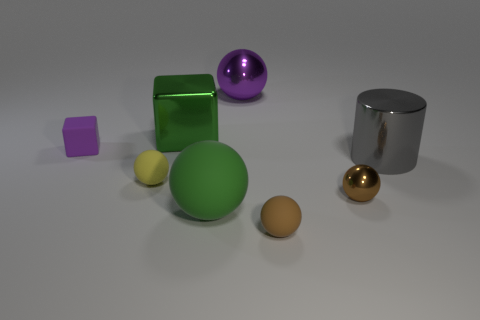What is the material of the object that is both behind the large green sphere and in front of the yellow sphere?
Your response must be concise. Metal. What is the color of the small rubber sphere right of the big sphere behind the yellow rubber ball?
Your answer should be very brief. Brown. What is the material of the tiny sphere left of the brown rubber object?
Provide a succinct answer. Rubber. Are there fewer rubber objects than large gray matte blocks?
Provide a short and direct response. No. There is a green metallic object; is its shape the same as the tiny thing that is behind the big cylinder?
Provide a short and direct response. Yes. There is a object that is right of the tiny brown rubber thing and behind the brown metal thing; what shape is it?
Your answer should be compact. Cylinder. Are there the same number of green metallic objects on the right side of the large green metal block and metallic things to the right of the large purple thing?
Provide a short and direct response. No. There is a small brown object on the right side of the tiny brown matte object; does it have the same shape as the green metallic thing?
Your answer should be very brief. No. What number of yellow things are either big matte balls or tiny metallic balls?
Offer a terse response. 0. There is another purple object that is the same shape as the big rubber thing; what is it made of?
Offer a very short reply. Metal. 